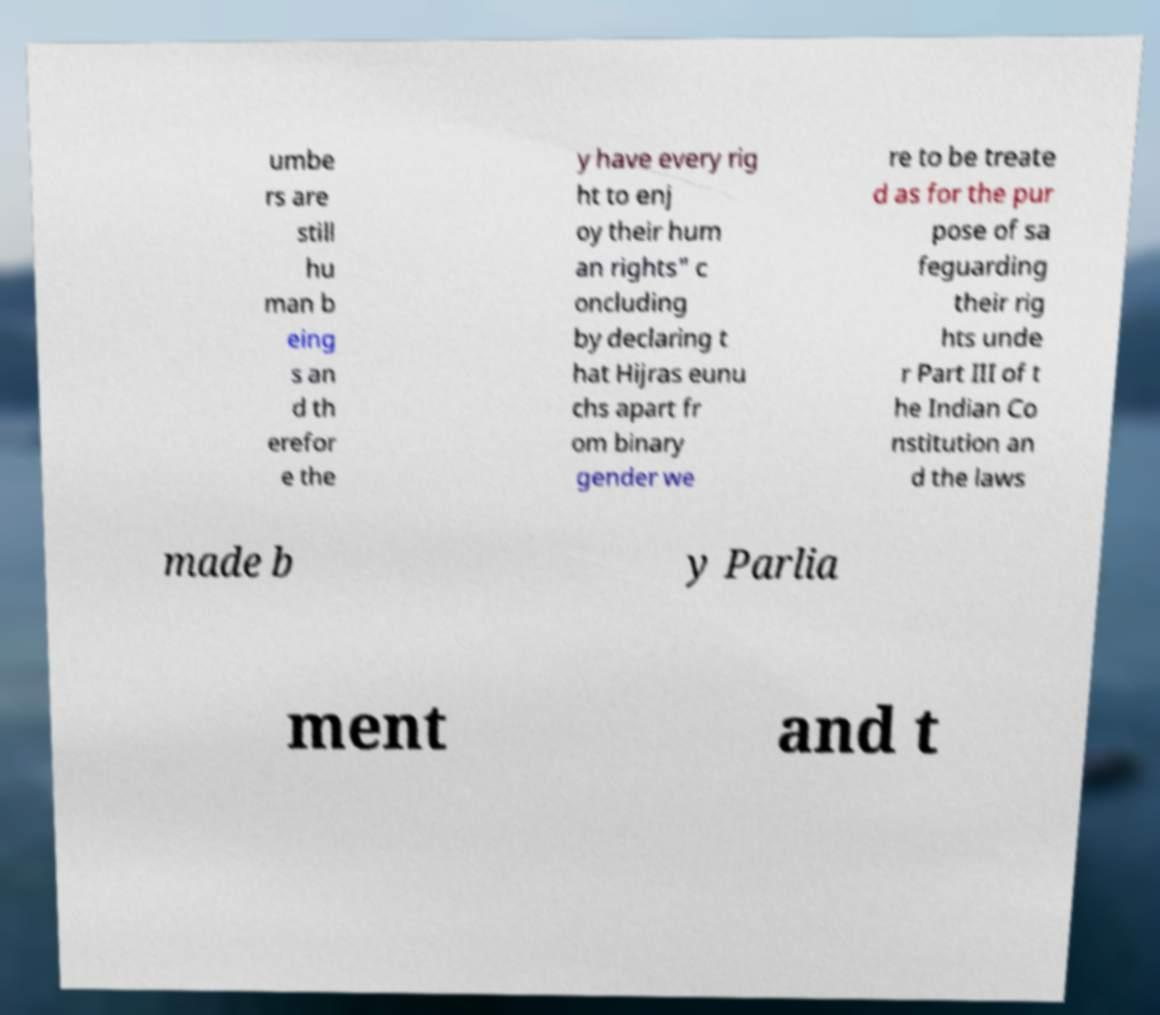For documentation purposes, I need the text within this image transcribed. Could you provide that? umbe rs are still hu man b eing s an d th erefor e the y have every rig ht to enj oy their hum an rights" c oncluding by declaring t hat Hijras eunu chs apart fr om binary gender we re to be treate d as for the pur pose of sa feguarding their rig hts unde r Part III of t he Indian Co nstitution an d the laws made b y Parlia ment and t 